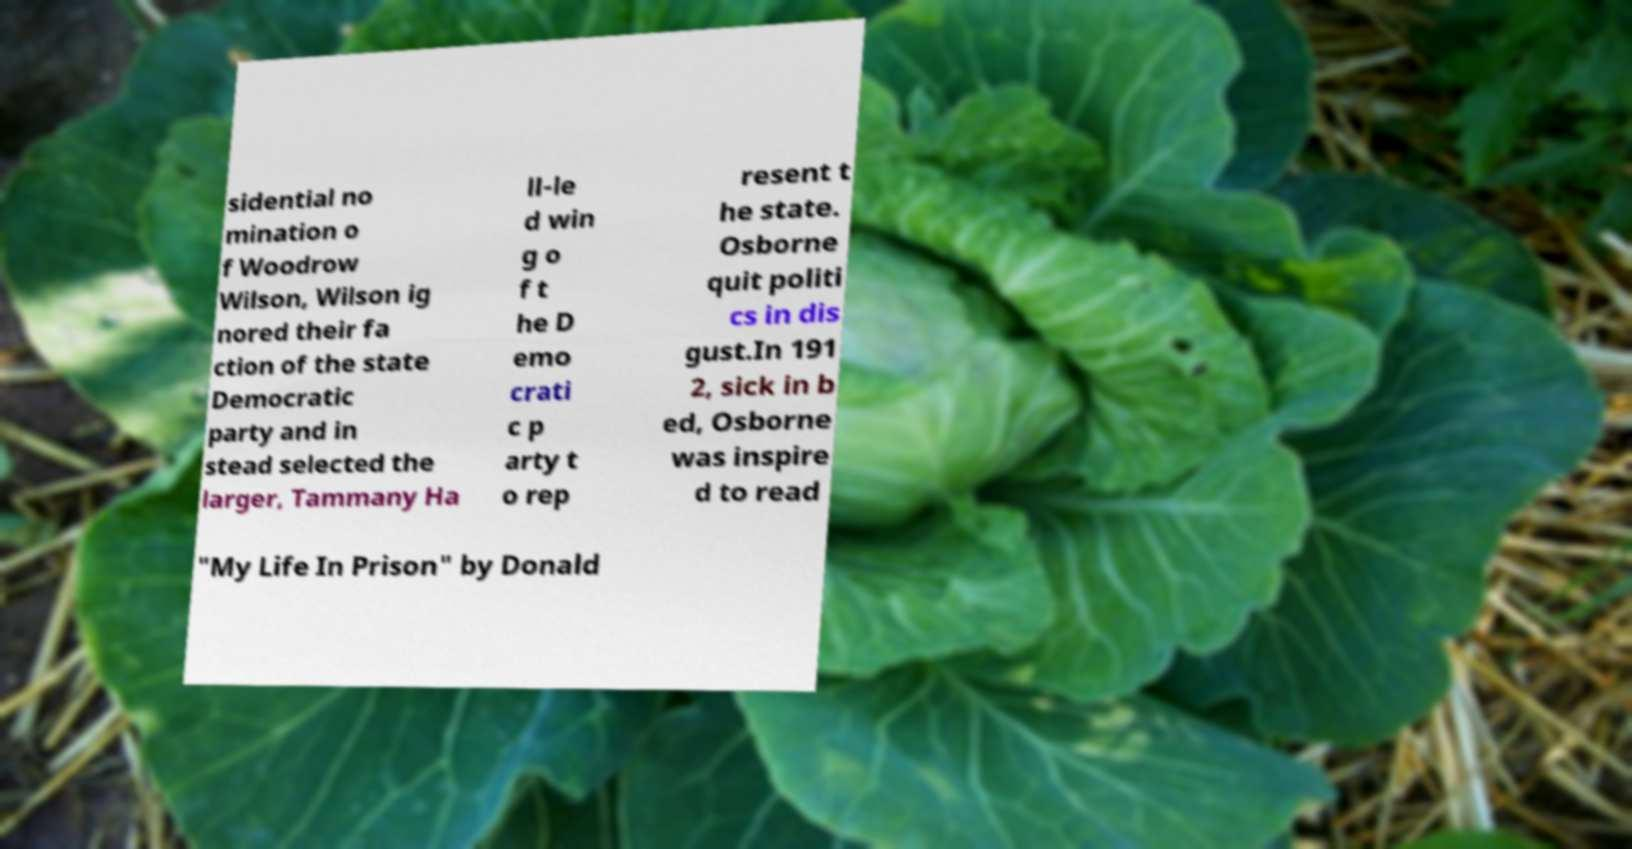What messages or text are displayed in this image? I need them in a readable, typed format. sidential no mination o f Woodrow Wilson, Wilson ig nored their fa ction of the state Democratic party and in stead selected the larger, Tammany Ha ll-le d win g o f t he D emo crati c p arty t o rep resent t he state. Osborne quit politi cs in dis gust.In 191 2, sick in b ed, Osborne was inspire d to read "My Life In Prison" by Donald 